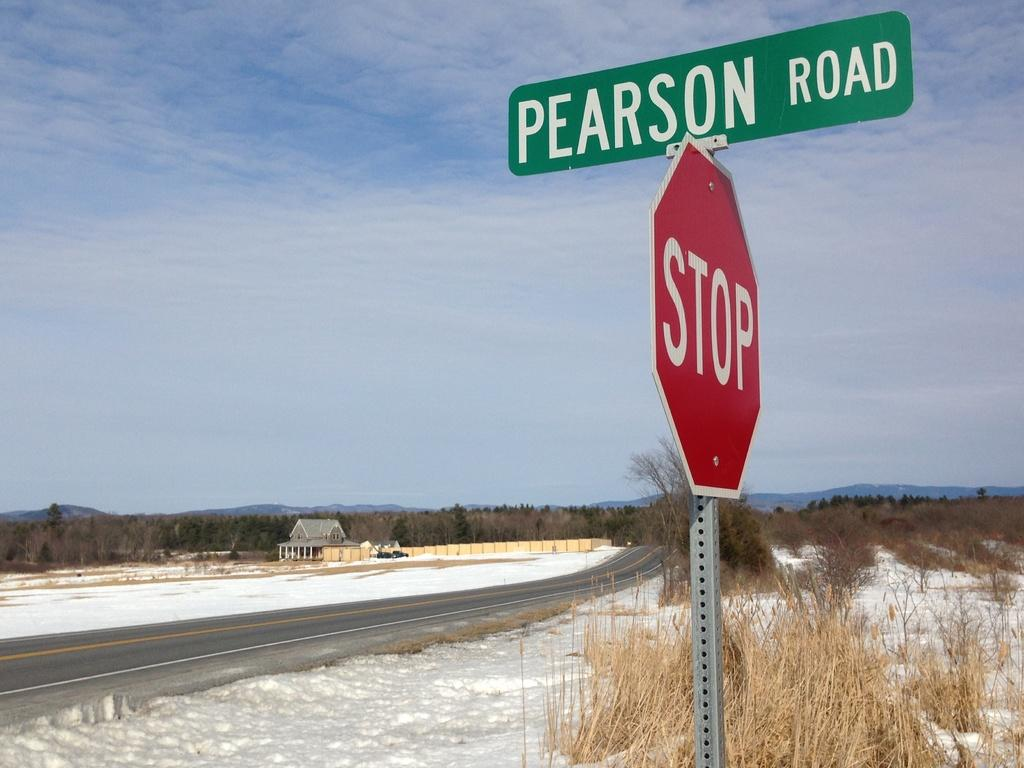<image>
Relay a brief, clear account of the picture shown. A red and white stop sign has a green street sign on top of it that reads pearson road. 